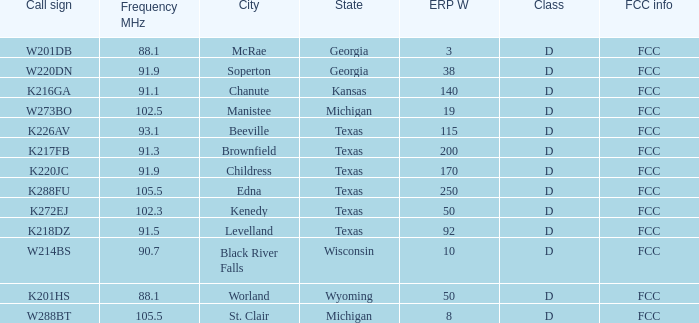What is the Sum of ERP W, when Call Sign is K216GA? 140.0. 